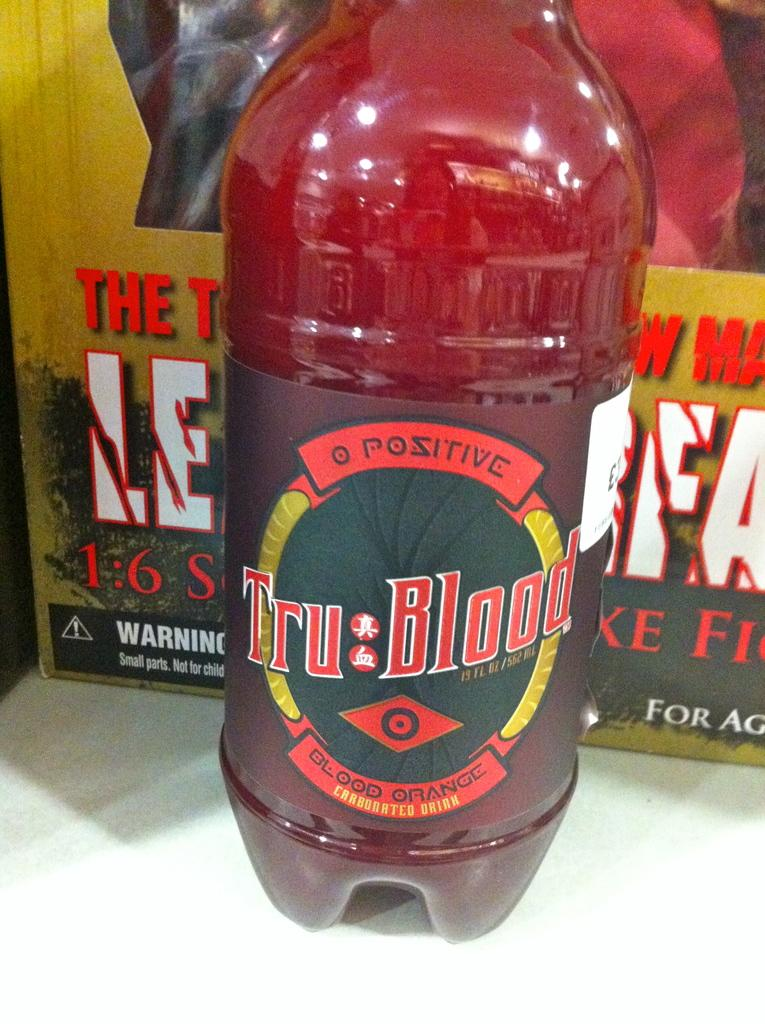What is in the bottle that is visible in the image? There is a bottle with a label in the image, and it contains a drink. What else can be seen in the background of the image? There is a box in the background of the image. What type of snow can be seen falling from the bottle in the image? There is no snow falling from the bottle in the image; it contains a drink. What type of expansion is occurring with the box in the image? There is no indication of expansion with the box in the image; it is simply present in the background. 